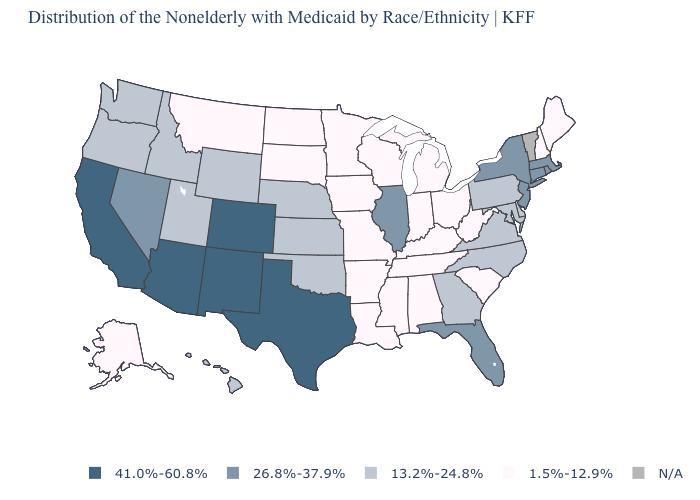What is the value of Tennessee?
Keep it brief. 1.5%-12.9%. How many symbols are there in the legend?
Be succinct. 5. What is the value of South Carolina?
Quick response, please. 1.5%-12.9%. Which states have the lowest value in the USA?
Keep it brief. Alabama, Alaska, Arkansas, Indiana, Iowa, Kentucky, Louisiana, Maine, Michigan, Minnesota, Mississippi, Missouri, Montana, New Hampshire, North Dakota, Ohio, South Carolina, South Dakota, Tennessee, West Virginia, Wisconsin. What is the value of Arizona?
Be succinct. 41.0%-60.8%. Which states hav the highest value in the South?
Answer briefly. Texas. Name the states that have a value in the range 13.2%-24.8%?
Give a very brief answer. Delaware, Georgia, Hawaii, Idaho, Kansas, Maryland, Nebraska, North Carolina, Oklahoma, Oregon, Pennsylvania, Utah, Virginia, Washington, Wyoming. What is the value of Nebraska?
Write a very short answer. 13.2%-24.8%. Is the legend a continuous bar?
Keep it brief. No. Among the states that border Florida , does Georgia have the lowest value?
Quick response, please. No. Name the states that have a value in the range 1.5%-12.9%?
Answer briefly. Alabama, Alaska, Arkansas, Indiana, Iowa, Kentucky, Louisiana, Maine, Michigan, Minnesota, Mississippi, Missouri, Montana, New Hampshire, North Dakota, Ohio, South Carolina, South Dakota, Tennessee, West Virginia, Wisconsin. Does the first symbol in the legend represent the smallest category?
Concise answer only. No. Is the legend a continuous bar?
Give a very brief answer. No. 